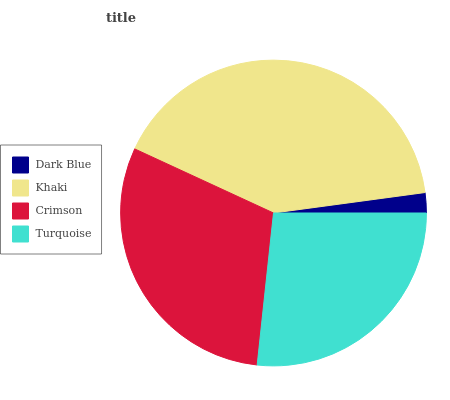Is Dark Blue the minimum?
Answer yes or no. Yes. Is Khaki the maximum?
Answer yes or no. Yes. Is Crimson the minimum?
Answer yes or no. No. Is Crimson the maximum?
Answer yes or no. No. Is Khaki greater than Crimson?
Answer yes or no. Yes. Is Crimson less than Khaki?
Answer yes or no. Yes. Is Crimson greater than Khaki?
Answer yes or no. No. Is Khaki less than Crimson?
Answer yes or no. No. Is Crimson the high median?
Answer yes or no. Yes. Is Turquoise the low median?
Answer yes or no. Yes. Is Dark Blue the high median?
Answer yes or no. No. Is Khaki the low median?
Answer yes or no. No. 